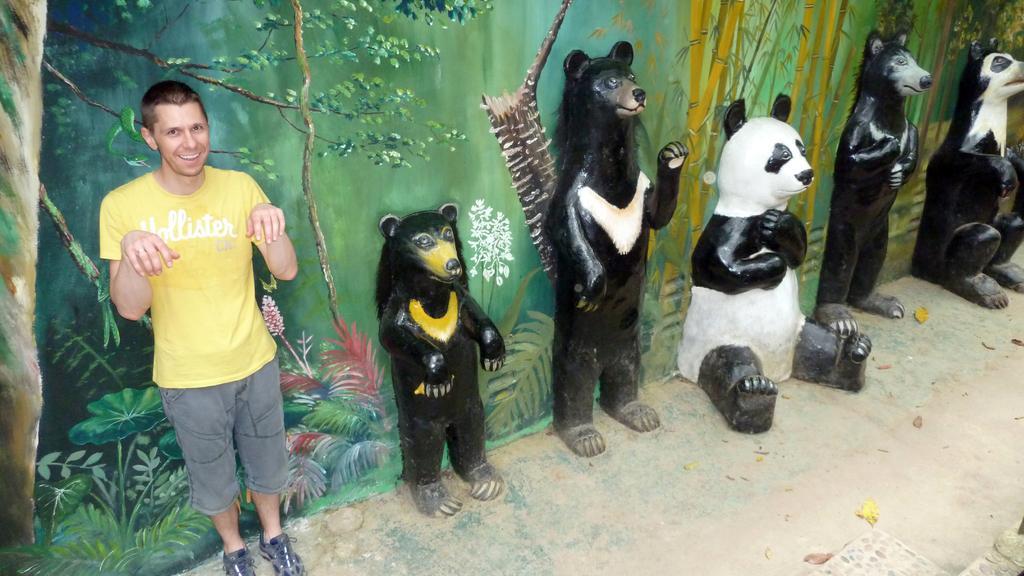Describe this image in one or two sentences. In this image we can see sculptures of animals. There is a painting of trees and plants on the wall. A person is standing in the image. 